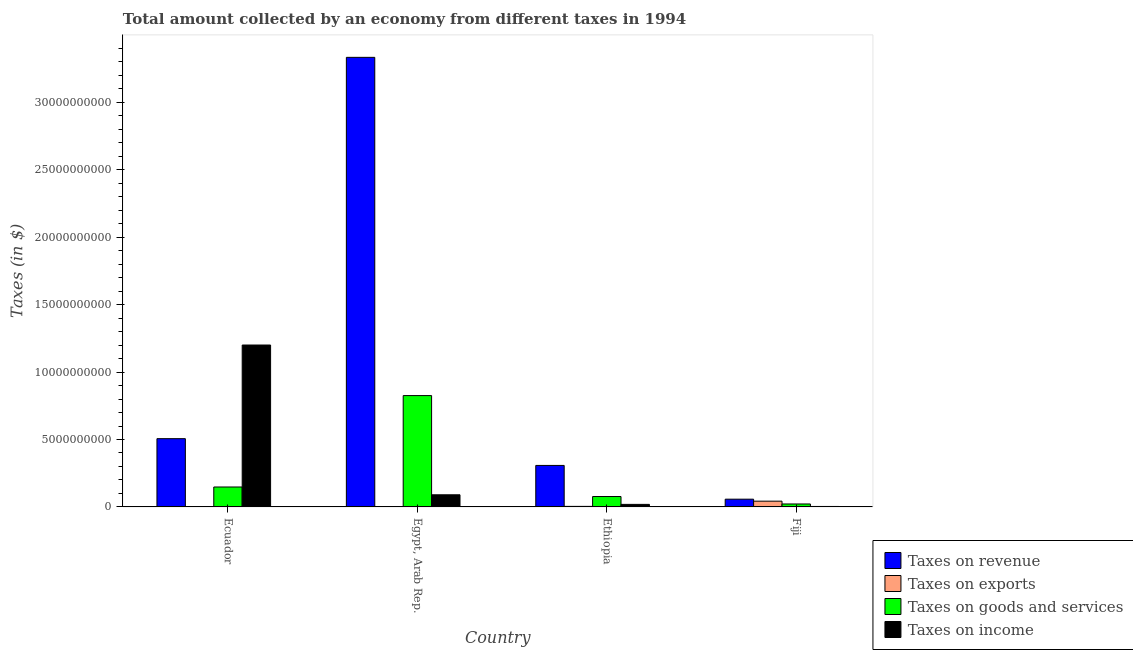How many groups of bars are there?
Your answer should be compact. 4. What is the label of the 1st group of bars from the left?
Give a very brief answer. Ecuador. What is the amount collected as tax on goods in Fiji?
Your answer should be very brief. 2.19e+08. Across all countries, what is the maximum amount collected as tax on revenue?
Your answer should be compact. 3.33e+1. Across all countries, what is the minimum amount collected as tax on goods?
Keep it short and to the point. 2.19e+08. In which country was the amount collected as tax on income maximum?
Your answer should be very brief. Ecuador. In which country was the amount collected as tax on revenue minimum?
Keep it short and to the point. Fiji. What is the total amount collected as tax on goods in the graph?
Offer a very short reply. 1.07e+1. What is the difference between the amount collected as tax on revenue in Egypt, Arab Rep. and that in Ethiopia?
Ensure brevity in your answer.  3.03e+1. What is the difference between the amount collected as tax on exports in Fiji and the amount collected as tax on goods in Egypt, Arab Rep.?
Offer a terse response. -7.83e+09. What is the average amount collected as tax on goods per country?
Offer a terse response. 2.68e+09. What is the difference between the amount collected as tax on exports and amount collected as tax on goods in Ethiopia?
Your response must be concise. -7.32e+08. What is the ratio of the amount collected as tax on income in Egypt, Arab Rep. to that in Fiji?
Offer a terse response. 25.85. Is the amount collected as tax on exports in Ethiopia less than that in Fiji?
Your answer should be very brief. Yes. Is the difference between the amount collected as tax on exports in Egypt, Arab Rep. and Fiji greater than the difference between the amount collected as tax on revenue in Egypt, Arab Rep. and Fiji?
Provide a short and direct response. No. What is the difference between the highest and the second highest amount collected as tax on goods?
Provide a short and direct response. 6.78e+09. What is the difference between the highest and the lowest amount collected as tax on goods?
Provide a short and direct response. 8.04e+09. In how many countries, is the amount collected as tax on exports greater than the average amount collected as tax on exports taken over all countries?
Your answer should be compact. 1. Is the sum of the amount collected as tax on goods in Egypt, Arab Rep. and Ethiopia greater than the maximum amount collected as tax on income across all countries?
Make the answer very short. No. What does the 2nd bar from the left in Ecuador represents?
Ensure brevity in your answer.  Taxes on exports. What does the 2nd bar from the right in Ecuador represents?
Offer a terse response. Taxes on goods and services. Is it the case that in every country, the sum of the amount collected as tax on revenue and amount collected as tax on exports is greater than the amount collected as tax on goods?
Offer a terse response. Yes. Are the values on the major ticks of Y-axis written in scientific E-notation?
Your answer should be very brief. No. Does the graph contain any zero values?
Ensure brevity in your answer.  No. Does the graph contain grids?
Ensure brevity in your answer.  No. How are the legend labels stacked?
Offer a terse response. Vertical. What is the title of the graph?
Offer a terse response. Total amount collected by an economy from different taxes in 1994. What is the label or title of the X-axis?
Make the answer very short. Country. What is the label or title of the Y-axis?
Your answer should be compact. Taxes (in $). What is the Taxes (in $) in Taxes on revenue in Ecuador?
Keep it short and to the point. 5.06e+09. What is the Taxes (in $) in Taxes on goods and services in Ecuador?
Offer a very short reply. 1.48e+09. What is the Taxes (in $) in Taxes on income in Ecuador?
Offer a very short reply. 1.20e+1. What is the Taxes (in $) of Taxes on revenue in Egypt, Arab Rep.?
Your answer should be very brief. 3.33e+1. What is the Taxes (in $) of Taxes on goods and services in Egypt, Arab Rep.?
Provide a succinct answer. 8.26e+09. What is the Taxes (in $) in Taxes on income in Egypt, Arab Rep.?
Make the answer very short. 9.00e+08. What is the Taxes (in $) of Taxes on revenue in Ethiopia?
Offer a terse response. 3.08e+09. What is the Taxes (in $) of Taxes on exports in Ethiopia?
Offer a terse response. 4.00e+07. What is the Taxes (in $) of Taxes on goods and services in Ethiopia?
Your answer should be very brief. 7.72e+08. What is the Taxes (in $) of Taxes on income in Ethiopia?
Offer a terse response. 1.89e+08. What is the Taxes (in $) in Taxes on revenue in Fiji?
Provide a succinct answer. 5.74e+08. What is the Taxes (in $) of Taxes on exports in Fiji?
Your answer should be compact. 4.27e+08. What is the Taxes (in $) of Taxes on goods and services in Fiji?
Give a very brief answer. 2.19e+08. What is the Taxes (in $) in Taxes on income in Fiji?
Keep it short and to the point. 3.48e+07. Across all countries, what is the maximum Taxes (in $) in Taxes on revenue?
Give a very brief answer. 3.33e+1. Across all countries, what is the maximum Taxes (in $) in Taxes on exports?
Give a very brief answer. 4.27e+08. Across all countries, what is the maximum Taxes (in $) in Taxes on goods and services?
Give a very brief answer. 8.26e+09. Across all countries, what is the maximum Taxes (in $) in Taxes on income?
Offer a terse response. 1.20e+1. Across all countries, what is the minimum Taxes (in $) of Taxes on revenue?
Provide a succinct answer. 5.74e+08. Across all countries, what is the minimum Taxes (in $) of Taxes on exports?
Keep it short and to the point. 1.00e+05. Across all countries, what is the minimum Taxes (in $) in Taxes on goods and services?
Give a very brief answer. 2.19e+08. Across all countries, what is the minimum Taxes (in $) in Taxes on income?
Your response must be concise. 3.48e+07. What is the total Taxes (in $) of Taxes on revenue in the graph?
Ensure brevity in your answer.  4.20e+1. What is the total Taxes (in $) of Taxes on exports in the graph?
Offer a very short reply. 4.71e+08. What is the total Taxes (in $) of Taxes on goods and services in the graph?
Your response must be concise. 1.07e+1. What is the total Taxes (in $) of Taxes on income in the graph?
Offer a terse response. 1.31e+1. What is the difference between the Taxes (in $) in Taxes on revenue in Ecuador and that in Egypt, Arab Rep.?
Your response must be concise. -2.83e+1. What is the difference between the Taxes (in $) of Taxes on exports in Ecuador and that in Egypt, Arab Rep.?
Give a very brief answer. 3.90e+06. What is the difference between the Taxes (in $) of Taxes on goods and services in Ecuador and that in Egypt, Arab Rep.?
Give a very brief answer. -6.78e+09. What is the difference between the Taxes (in $) of Taxes on income in Ecuador and that in Egypt, Arab Rep.?
Offer a very short reply. 1.11e+1. What is the difference between the Taxes (in $) of Taxes on revenue in Ecuador and that in Ethiopia?
Ensure brevity in your answer.  1.98e+09. What is the difference between the Taxes (in $) of Taxes on exports in Ecuador and that in Ethiopia?
Make the answer very short. -3.60e+07. What is the difference between the Taxes (in $) in Taxes on goods and services in Ecuador and that in Ethiopia?
Keep it short and to the point. 7.06e+08. What is the difference between the Taxes (in $) of Taxes on income in Ecuador and that in Ethiopia?
Give a very brief answer. 1.18e+1. What is the difference between the Taxes (in $) of Taxes on revenue in Ecuador and that in Fiji?
Ensure brevity in your answer.  4.49e+09. What is the difference between the Taxes (in $) in Taxes on exports in Ecuador and that in Fiji?
Make the answer very short. -4.23e+08. What is the difference between the Taxes (in $) of Taxes on goods and services in Ecuador and that in Fiji?
Keep it short and to the point. 1.26e+09. What is the difference between the Taxes (in $) of Taxes on income in Ecuador and that in Fiji?
Make the answer very short. 1.20e+1. What is the difference between the Taxes (in $) in Taxes on revenue in Egypt, Arab Rep. and that in Ethiopia?
Give a very brief answer. 3.03e+1. What is the difference between the Taxes (in $) in Taxes on exports in Egypt, Arab Rep. and that in Ethiopia?
Keep it short and to the point. -3.99e+07. What is the difference between the Taxes (in $) in Taxes on goods and services in Egypt, Arab Rep. and that in Ethiopia?
Ensure brevity in your answer.  7.48e+09. What is the difference between the Taxes (in $) of Taxes on income in Egypt, Arab Rep. and that in Ethiopia?
Provide a short and direct response. 7.11e+08. What is the difference between the Taxes (in $) in Taxes on revenue in Egypt, Arab Rep. and that in Fiji?
Your response must be concise. 3.28e+1. What is the difference between the Taxes (in $) in Taxes on exports in Egypt, Arab Rep. and that in Fiji?
Ensure brevity in your answer.  -4.27e+08. What is the difference between the Taxes (in $) of Taxes on goods and services in Egypt, Arab Rep. and that in Fiji?
Your response must be concise. 8.04e+09. What is the difference between the Taxes (in $) in Taxes on income in Egypt, Arab Rep. and that in Fiji?
Ensure brevity in your answer.  8.65e+08. What is the difference between the Taxes (in $) of Taxes on revenue in Ethiopia and that in Fiji?
Offer a terse response. 2.50e+09. What is the difference between the Taxes (in $) of Taxes on exports in Ethiopia and that in Fiji?
Provide a short and direct response. -3.87e+08. What is the difference between the Taxes (in $) of Taxes on goods and services in Ethiopia and that in Fiji?
Your response must be concise. 5.53e+08. What is the difference between the Taxes (in $) of Taxes on income in Ethiopia and that in Fiji?
Offer a very short reply. 1.54e+08. What is the difference between the Taxes (in $) in Taxes on revenue in Ecuador and the Taxes (in $) in Taxes on exports in Egypt, Arab Rep.?
Provide a succinct answer. 5.06e+09. What is the difference between the Taxes (in $) in Taxes on revenue in Ecuador and the Taxes (in $) in Taxes on goods and services in Egypt, Arab Rep.?
Offer a very short reply. -3.19e+09. What is the difference between the Taxes (in $) in Taxes on revenue in Ecuador and the Taxes (in $) in Taxes on income in Egypt, Arab Rep.?
Offer a terse response. 4.16e+09. What is the difference between the Taxes (in $) of Taxes on exports in Ecuador and the Taxes (in $) of Taxes on goods and services in Egypt, Arab Rep.?
Keep it short and to the point. -8.25e+09. What is the difference between the Taxes (in $) in Taxes on exports in Ecuador and the Taxes (in $) in Taxes on income in Egypt, Arab Rep.?
Keep it short and to the point. -8.96e+08. What is the difference between the Taxes (in $) of Taxes on goods and services in Ecuador and the Taxes (in $) of Taxes on income in Egypt, Arab Rep.?
Provide a succinct answer. 5.78e+08. What is the difference between the Taxes (in $) of Taxes on revenue in Ecuador and the Taxes (in $) of Taxes on exports in Ethiopia?
Give a very brief answer. 5.02e+09. What is the difference between the Taxes (in $) of Taxes on revenue in Ecuador and the Taxes (in $) of Taxes on goods and services in Ethiopia?
Your answer should be very brief. 4.29e+09. What is the difference between the Taxes (in $) of Taxes on revenue in Ecuador and the Taxes (in $) of Taxes on income in Ethiopia?
Make the answer very short. 4.87e+09. What is the difference between the Taxes (in $) of Taxes on exports in Ecuador and the Taxes (in $) of Taxes on goods and services in Ethiopia?
Ensure brevity in your answer.  -7.68e+08. What is the difference between the Taxes (in $) of Taxes on exports in Ecuador and the Taxes (in $) of Taxes on income in Ethiopia?
Your response must be concise. -1.85e+08. What is the difference between the Taxes (in $) in Taxes on goods and services in Ecuador and the Taxes (in $) in Taxes on income in Ethiopia?
Your response must be concise. 1.29e+09. What is the difference between the Taxes (in $) in Taxes on revenue in Ecuador and the Taxes (in $) in Taxes on exports in Fiji?
Provide a succinct answer. 4.63e+09. What is the difference between the Taxes (in $) of Taxes on revenue in Ecuador and the Taxes (in $) of Taxes on goods and services in Fiji?
Give a very brief answer. 4.84e+09. What is the difference between the Taxes (in $) in Taxes on revenue in Ecuador and the Taxes (in $) in Taxes on income in Fiji?
Give a very brief answer. 5.03e+09. What is the difference between the Taxes (in $) of Taxes on exports in Ecuador and the Taxes (in $) of Taxes on goods and services in Fiji?
Your response must be concise. -2.15e+08. What is the difference between the Taxes (in $) in Taxes on exports in Ecuador and the Taxes (in $) in Taxes on income in Fiji?
Your answer should be compact. -3.08e+07. What is the difference between the Taxes (in $) in Taxes on goods and services in Ecuador and the Taxes (in $) in Taxes on income in Fiji?
Your response must be concise. 1.44e+09. What is the difference between the Taxes (in $) of Taxes on revenue in Egypt, Arab Rep. and the Taxes (in $) of Taxes on exports in Ethiopia?
Ensure brevity in your answer.  3.33e+1. What is the difference between the Taxes (in $) of Taxes on revenue in Egypt, Arab Rep. and the Taxes (in $) of Taxes on goods and services in Ethiopia?
Your answer should be very brief. 3.26e+1. What is the difference between the Taxes (in $) of Taxes on revenue in Egypt, Arab Rep. and the Taxes (in $) of Taxes on income in Ethiopia?
Your answer should be compact. 3.31e+1. What is the difference between the Taxes (in $) of Taxes on exports in Egypt, Arab Rep. and the Taxes (in $) of Taxes on goods and services in Ethiopia?
Offer a terse response. -7.72e+08. What is the difference between the Taxes (in $) in Taxes on exports in Egypt, Arab Rep. and the Taxes (in $) in Taxes on income in Ethiopia?
Provide a short and direct response. -1.89e+08. What is the difference between the Taxes (in $) of Taxes on goods and services in Egypt, Arab Rep. and the Taxes (in $) of Taxes on income in Ethiopia?
Provide a short and direct response. 8.07e+09. What is the difference between the Taxes (in $) of Taxes on revenue in Egypt, Arab Rep. and the Taxes (in $) of Taxes on exports in Fiji?
Offer a very short reply. 3.29e+1. What is the difference between the Taxes (in $) of Taxes on revenue in Egypt, Arab Rep. and the Taxes (in $) of Taxes on goods and services in Fiji?
Provide a succinct answer. 3.31e+1. What is the difference between the Taxes (in $) of Taxes on revenue in Egypt, Arab Rep. and the Taxes (in $) of Taxes on income in Fiji?
Your answer should be very brief. 3.33e+1. What is the difference between the Taxes (in $) of Taxes on exports in Egypt, Arab Rep. and the Taxes (in $) of Taxes on goods and services in Fiji?
Offer a terse response. -2.19e+08. What is the difference between the Taxes (in $) of Taxes on exports in Egypt, Arab Rep. and the Taxes (in $) of Taxes on income in Fiji?
Keep it short and to the point. -3.47e+07. What is the difference between the Taxes (in $) of Taxes on goods and services in Egypt, Arab Rep. and the Taxes (in $) of Taxes on income in Fiji?
Your response must be concise. 8.22e+09. What is the difference between the Taxes (in $) in Taxes on revenue in Ethiopia and the Taxes (in $) in Taxes on exports in Fiji?
Offer a very short reply. 2.65e+09. What is the difference between the Taxes (in $) in Taxes on revenue in Ethiopia and the Taxes (in $) in Taxes on goods and services in Fiji?
Offer a terse response. 2.86e+09. What is the difference between the Taxes (in $) in Taxes on revenue in Ethiopia and the Taxes (in $) in Taxes on income in Fiji?
Offer a terse response. 3.04e+09. What is the difference between the Taxes (in $) in Taxes on exports in Ethiopia and the Taxes (in $) in Taxes on goods and services in Fiji?
Give a very brief answer. -1.79e+08. What is the difference between the Taxes (in $) of Taxes on exports in Ethiopia and the Taxes (in $) of Taxes on income in Fiji?
Offer a terse response. 5.20e+06. What is the difference between the Taxes (in $) of Taxes on goods and services in Ethiopia and the Taxes (in $) of Taxes on income in Fiji?
Offer a very short reply. 7.37e+08. What is the average Taxes (in $) of Taxes on revenue per country?
Keep it short and to the point. 1.05e+1. What is the average Taxes (in $) of Taxes on exports per country?
Make the answer very short. 1.18e+08. What is the average Taxes (in $) in Taxes on goods and services per country?
Offer a terse response. 2.68e+09. What is the average Taxes (in $) in Taxes on income per country?
Your answer should be very brief. 3.28e+09. What is the difference between the Taxes (in $) in Taxes on revenue and Taxes (in $) in Taxes on exports in Ecuador?
Give a very brief answer. 5.06e+09. What is the difference between the Taxes (in $) in Taxes on revenue and Taxes (in $) in Taxes on goods and services in Ecuador?
Your answer should be compact. 3.58e+09. What is the difference between the Taxes (in $) of Taxes on revenue and Taxes (in $) of Taxes on income in Ecuador?
Offer a very short reply. -6.94e+09. What is the difference between the Taxes (in $) in Taxes on exports and Taxes (in $) in Taxes on goods and services in Ecuador?
Your answer should be very brief. -1.47e+09. What is the difference between the Taxes (in $) of Taxes on exports and Taxes (in $) of Taxes on income in Ecuador?
Your answer should be compact. -1.20e+1. What is the difference between the Taxes (in $) of Taxes on goods and services and Taxes (in $) of Taxes on income in Ecuador?
Your response must be concise. -1.05e+1. What is the difference between the Taxes (in $) of Taxes on revenue and Taxes (in $) of Taxes on exports in Egypt, Arab Rep.?
Keep it short and to the point. 3.33e+1. What is the difference between the Taxes (in $) in Taxes on revenue and Taxes (in $) in Taxes on goods and services in Egypt, Arab Rep.?
Give a very brief answer. 2.51e+1. What is the difference between the Taxes (in $) in Taxes on revenue and Taxes (in $) in Taxes on income in Egypt, Arab Rep.?
Keep it short and to the point. 3.24e+1. What is the difference between the Taxes (in $) in Taxes on exports and Taxes (in $) in Taxes on goods and services in Egypt, Arab Rep.?
Your response must be concise. -8.25e+09. What is the difference between the Taxes (in $) of Taxes on exports and Taxes (in $) of Taxes on income in Egypt, Arab Rep.?
Your response must be concise. -9.00e+08. What is the difference between the Taxes (in $) of Taxes on goods and services and Taxes (in $) of Taxes on income in Egypt, Arab Rep.?
Make the answer very short. 7.36e+09. What is the difference between the Taxes (in $) in Taxes on revenue and Taxes (in $) in Taxes on exports in Ethiopia?
Make the answer very short. 3.04e+09. What is the difference between the Taxes (in $) of Taxes on revenue and Taxes (in $) of Taxes on goods and services in Ethiopia?
Your answer should be very brief. 2.30e+09. What is the difference between the Taxes (in $) of Taxes on revenue and Taxes (in $) of Taxes on income in Ethiopia?
Keep it short and to the point. 2.89e+09. What is the difference between the Taxes (in $) of Taxes on exports and Taxes (in $) of Taxes on goods and services in Ethiopia?
Ensure brevity in your answer.  -7.32e+08. What is the difference between the Taxes (in $) in Taxes on exports and Taxes (in $) in Taxes on income in Ethiopia?
Provide a succinct answer. -1.49e+08. What is the difference between the Taxes (in $) in Taxes on goods and services and Taxes (in $) in Taxes on income in Ethiopia?
Your response must be concise. 5.83e+08. What is the difference between the Taxes (in $) in Taxes on revenue and Taxes (in $) in Taxes on exports in Fiji?
Make the answer very short. 1.47e+08. What is the difference between the Taxes (in $) in Taxes on revenue and Taxes (in $) in Taxes on goods and services in Fiji?
Your answer should be compact. 3.55e+08. What is the difference between the Taxes (in $) of Taxes on revenue and Taxes (in $) of Taxes on income in Fiji?
Your response must be concise. 5.40e+08. What is the difference between the Taxes (in $) of Taxes on exports and Taxes (in $) of Taxes on goods and services in Fiji?
Ensure brevity in your answer.  2.08e+08. What is the difference between the Taxes (in $) in Taxes on exports and Taxes (in $) in Taxes on income in Fiji?
Keep it short and to the point. 3.92e+08. What is the difference between the Taxes (in $) of Taxes on goods and services and Taxes (in $) of Taxes on income in Fiji?
Make the answer very short. 1.84e+08. What is the ratio of the Taxes (in $) of Taxes on revenue in Ecuador to that in Egypt, Arab Rep.?
Make the answer very short. 0.15. What is the ratio of the Taxes (in $) in Taxes on goods and services in Ecuador to that in Egypt, Arab Rep.?
Ensure brevity in your answer.  0.18. What is the ratio of the Taxes (in $) of Taxes on income in Ecuador to that in Egypt, Arab Rep.?
Provide a succinct answer. 13.34. What is the ratio of the Taxes (in $) in Taxes on revenue in Ecuador to that in Ethiopia?
Provide a succinct answer. 1.65. What is the ratio of the Taxes (in $) of Taxes on exports in Ecuador to that in Ethiopia?
Provide a succinct answer. 0.1. What is the ratio of the Taxes (in $) of Taxes on goods and services in Ecuador to that in Ethiopia?
Offer a terse response. 1.92. What is the ratio of the Taxes (in $) in Taxes on income in Ecuador to that in Ethiopia?
Your response must be concise. 63.49. What is the ratio of the Taxes (in $) of Taxes on revenue in Ecuador to that in Fiji?
Give a very brief answer. 8.81. What is the ratio of the Taxes (in $) in Taxes on exports in Ecuador to that in Fiji?
Ensure brevity in your answer.  0.01. What is the ratio of the Taxes (in $) of Taxes on goods and services in Ecuador to that in Fiji?
Give a very brief answer. 6.74. What is the ratio of the Taxes (in $) in Taxes on income in Ecuador to that in Fiji?
Provide a short and direct response. 344.94. What is the ratio of the Taxes (in $) in Taxes on revenue in Egypt, Arab Rep. to that in Ethiopia?
Ensure brevity in your answer.  10.84. What is the ratio of the Taxes (in $) of Taxes on exports in Egypt, Arab Rep. to that in Ethiopia?
Ensure brevity in your answer.  0. What is the ratio of the Taxes (in $) in Taxes on goods and services in Egypt, Arab Rep. to that in Ethiopia?
Offer a very short reply. 10.7. What is the ratio of the Taxes (in $) of Taxes on income in Egypt, Arab Rep. to that in Ethiopia?
Provide a succinct answer. 4.76. What is the ratio of the Taxes (in $) of Taxes on revenue in Egypt, Arab Rep. to that in Fiji?
Keep it short and to the point. 58.03. What is the ratio of the Taxes (in $) of Taxes on goods and services in Egypt, Arab Rep. to that in Fiji?
Your answer should be very brief. 37.67. What is the ratio of the Taxes (in $) in Taxes on income in Egypt, Arab Rep. to that in Fiji?
Your answer should be compact. 25.85. What is the ratio of the Taxes (in $) in Taxes on revenue in Ethiopia to that in Fiji?
Your response must be concise. 5.36. What is the ratio of the Taxes (in $) of Taxes on exports in Ethiopia to that in Fiji?
Your answer should be very brief. 0.09. What is the ratio of the Taxes (in $) of Taxes on goods and services in Ethiopia to that in Fiji?
Offer a terse response. 3.52. What is the ratio of the Taxes (in $) in Taxes on income in Ethiopia to that in Fiji?
Your response must be concise. 5.43. What is the difference between the highest and the second highest Taxes (in $) in Taxes on revenue?
Offer a very short reply. 2.83e+1. What is the difference between the highest and the second highest Taxes (in $) in Taxes on exports?
Make the answer very short. 3.87e+08. What is the difference between the highest and the second highest Taxes (in $) of Taxes on goods and services?
Offer a terse response. 6.78e+09. What is the difference between the highest and the second highest Taxes (in $) in Taxes on income?
Make the answer very short. 1.11e+1. What is the difference between the highest and the lowest Taxes (in $) of Taxes on revenue?
Ensure brevity in your answer.  3.28e+1. What is the difference between the highest and the lowest Taxes (in $) in Taxes on exports?
Give a very brief answer. 4.27e+08. What is the difference between the highest and the lowest Taxes (in $) of Taxes on goods and services?
Your answer should be very brief. 8.04e+09. What is the difference between the highest and the lowest Taxes (in $) of Taxes on income?
Make the answer very short. 1.20e+1. 